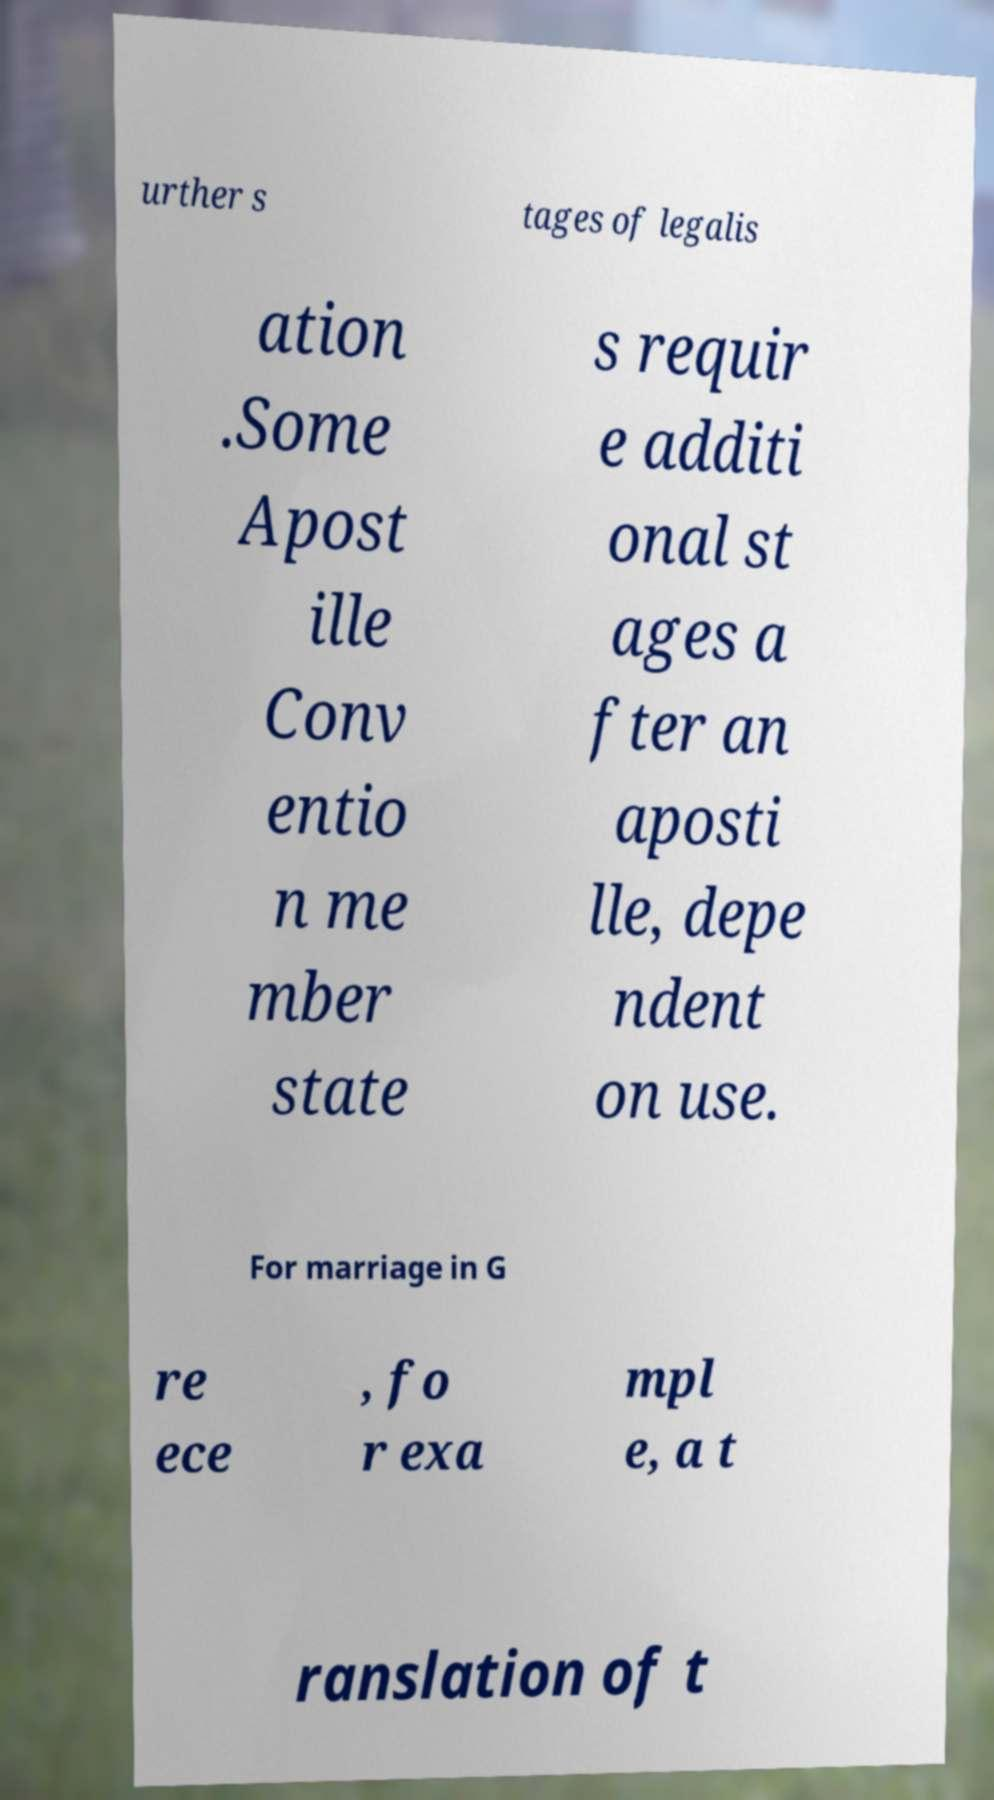Can you accurately transcribe the text from the provided image for me? urther s tages of legalis ation .Some Apost ille Conv entio n me mber state s requir e additi onal st ages a fter an aposti lle, depe ndent on use. For marriage in G re ece , fo r exa mpl e, a t ranslation of t 